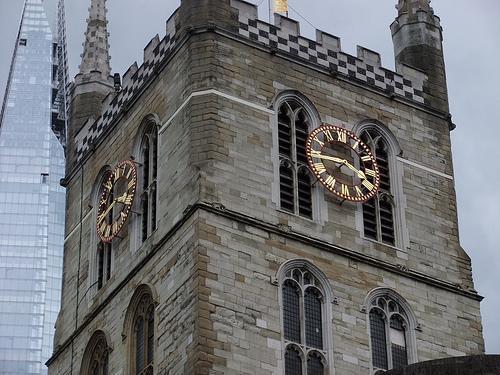How many clocks are in the picture?
Give a very brief answer. 2. 